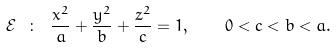Convert formula to latex. <formula><loc_0><loc_0><loc_500><loc_500>\mathcal { E } \ \colon \ \frac { x ^ { 2 } } a + \frac { y ^ { 2 } } b + \frac { z ^ { 2 } } c = 1 , \quad 0 < c < b < a .</formula> 